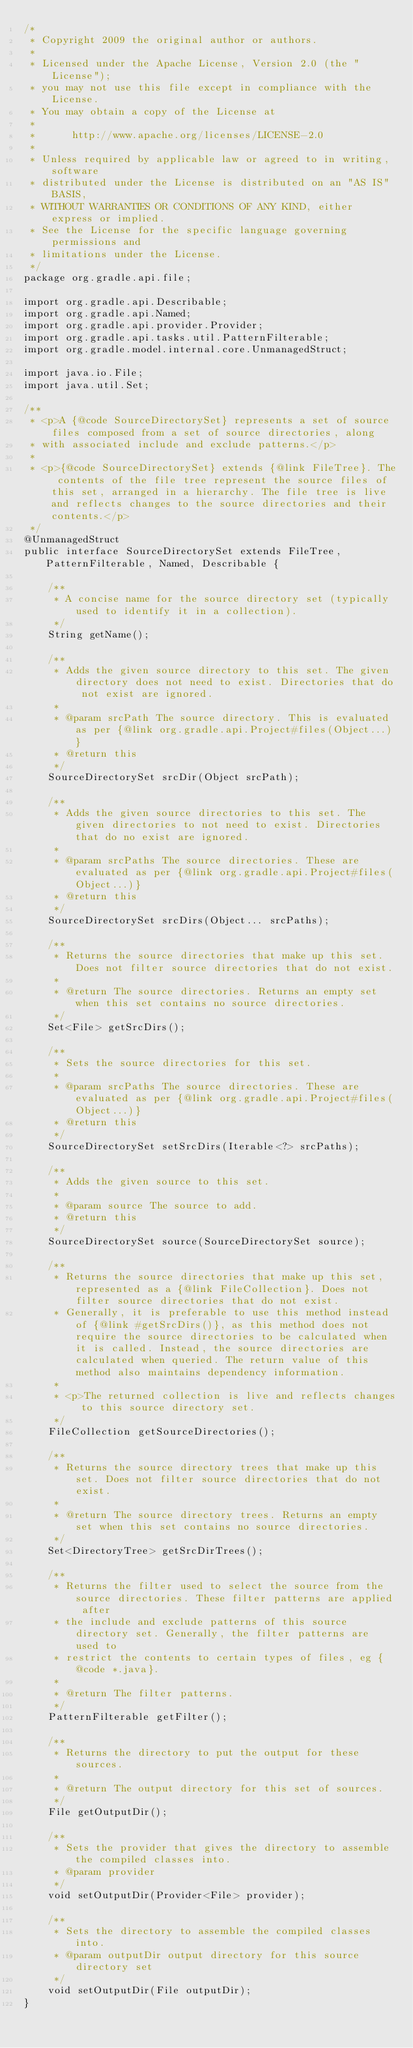<code> <loc_0><loc_0><loc_500><loc_500><_Java_>/*
 * Copyright 2009 the original author or authors.
 *
 * Licensed under the Apache License, Version 2.0 (the "License");
 * you may not use this file except in compliance with the License.
 * You may obtain a copy of the License at
 *
 *      http://www.apache.org/licenses/LICENSE-2.0
 *
 * Unless required by applicable law or agreed to in writing, software
 * distributed under the License is distributed on an "AS IS" BASIS,
 * WITHOUT WARRANTIES OR CONDITIONS OF ANY KIND, either express or implied.
 * See the License for the specific language governing permissions and
 * limitations under the License.
 */
package org.gradle.api.file;

import org.gradle.api.Describable;
import org.gradle.api.Named;
import org.gradle.api.provider.Provider;
import org.gradle.api.tasks.util.PatternFilterable;
import org.gradle.model.internal.core.UnmanagedStruct;

import java.io.File;
import java.util.Set;

/**
 * <p>A {@code SourceDirectorySet} represents a set of source files composed from a set of source directories, along
 * with associated include and exclude patterns.</p>
 *
 * <p>{@code SourceDirectorySet} extends {@link FileTree}. The contents of the file tree represent the source files of this set, arranged in a hierarchy. The file tree is live and reflects changes to the source directories and their contents.</p>
 */
@UnmanagedStruct
public interface SourceDirectorySet extends FileTree, PatternFilterable, Named, Describable {

    /**
     * A concise name for the source directory set (typically used to identify it in a collection).
     */
    String getName();

    /**
     * Adds the given source directory to this set. The given directory does not need to exist. Directories that do not exist are ignored.
     *
     * @param srcPath The source directory. This is evaluated as per {@link org.gradle.api.Project#files(Object...)}
     * @return this
     */
    SourceDirectorySet srcDir(Object srcPath);

    /**
     * Adds the given source directories to this set. The given directories to not need to exist. Directories that do no exist are ignored.
     *
     * @param srcPaths The source directories. These are evaluated as per {@link org.gradle.api.Project#files(Object...)}
     * @return this
     */
    SourceDirectorySet srcDirs(Object... srcPaths);

    /**
     * Returns the source directories that make up this set. Does not filter source directories that do not exist.
     *
     * @return The source directories. Returns an empty set when this set contains no source directories.
     */
    Set<File> getSrcDirs();

    /**
     * Sets the source directories for this set.
     *
     * @param srcPaths The source directories. These are evaluated as per {@link org.gradle.api.Project#files(Object...)}
     * @return this
     */
    SourceDirectorySet setSrcDirs(Iterable<?> srcPaths);

    /**
     * Adds the given source to this set.
     *
     * @param source The source to add.
     * @return this
     */
    SourceDirectorySet source(SourceDirectorySet source);

    /**
     * Returns the source directories that make up this set, represented as a {@link FileCollection}. Does not filter source directories that do not exist.
     * Generally, it is preferable to use this method instead of {@link #getSrcDirs()}, as this method does not require the source directories to be calculated when it is called. Instead, the source directories are calculated when queried. The return value of this method also maintains dependency information.
     *
     * <p>The returned collection is live and reflects changes to this source directory set.
     */
    FileCollection getSourceDirectories();

    /**
     * Returns the source directory trees that make up this set. Does not filter source directories that do not exist.
     *
     * @return The source directory trees. Returns an empty set when this set contains no source directories.
     */
    Set<DirectoryTree> getSrcDirTrees();

    /**
     * Returns the filter used to select the source from the source directories. These filter patterns are applied after
     * the include and exclude patterns of this source directory set. Generally, the filter patterns are used to
     * restrict the contents to certain types of files, eg {@code *.java}.
     *
     * @return The filter patterns.
     */
    PatternFilterable getFilter();

    /**
     * Returns the directory to put the output for these sources.
     *
     * @return The output directory for this set of sources.
     */
    File getOutputDir();

    /**
     * Sets the provider that gives the directory to assemble the compiled classes into.
     * @param provider
     */
    void setOutputDir(Provider<File> provider);

    /**
     * Sets the directory to assemble the compiled classes into.
     * @param outputDir output directory for this source directory set
     */
    void setOutputDir(File outputDir);
}
</code> 